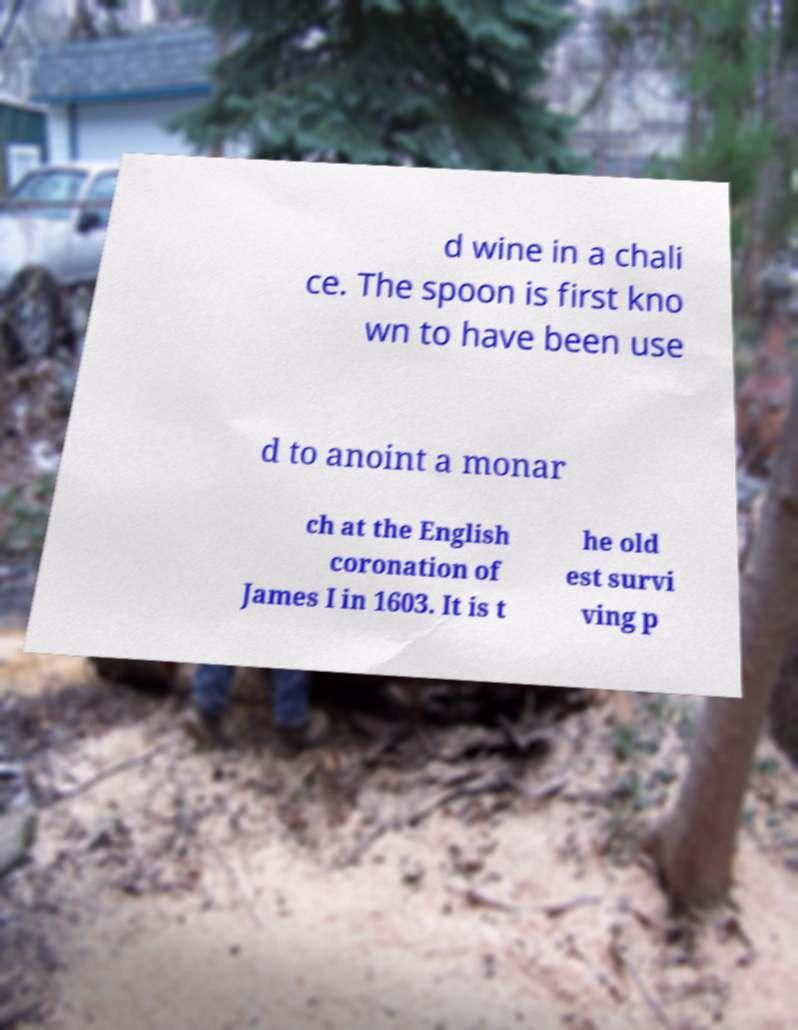There's text embedded in this image that I need extracted. Can you transcribe it verbatim? d wine in a chali ce. The spoon is first kno wn to have been use d to anoint a monar ch at the English coronation of James I in 1603. It is t he old est survi ving p 